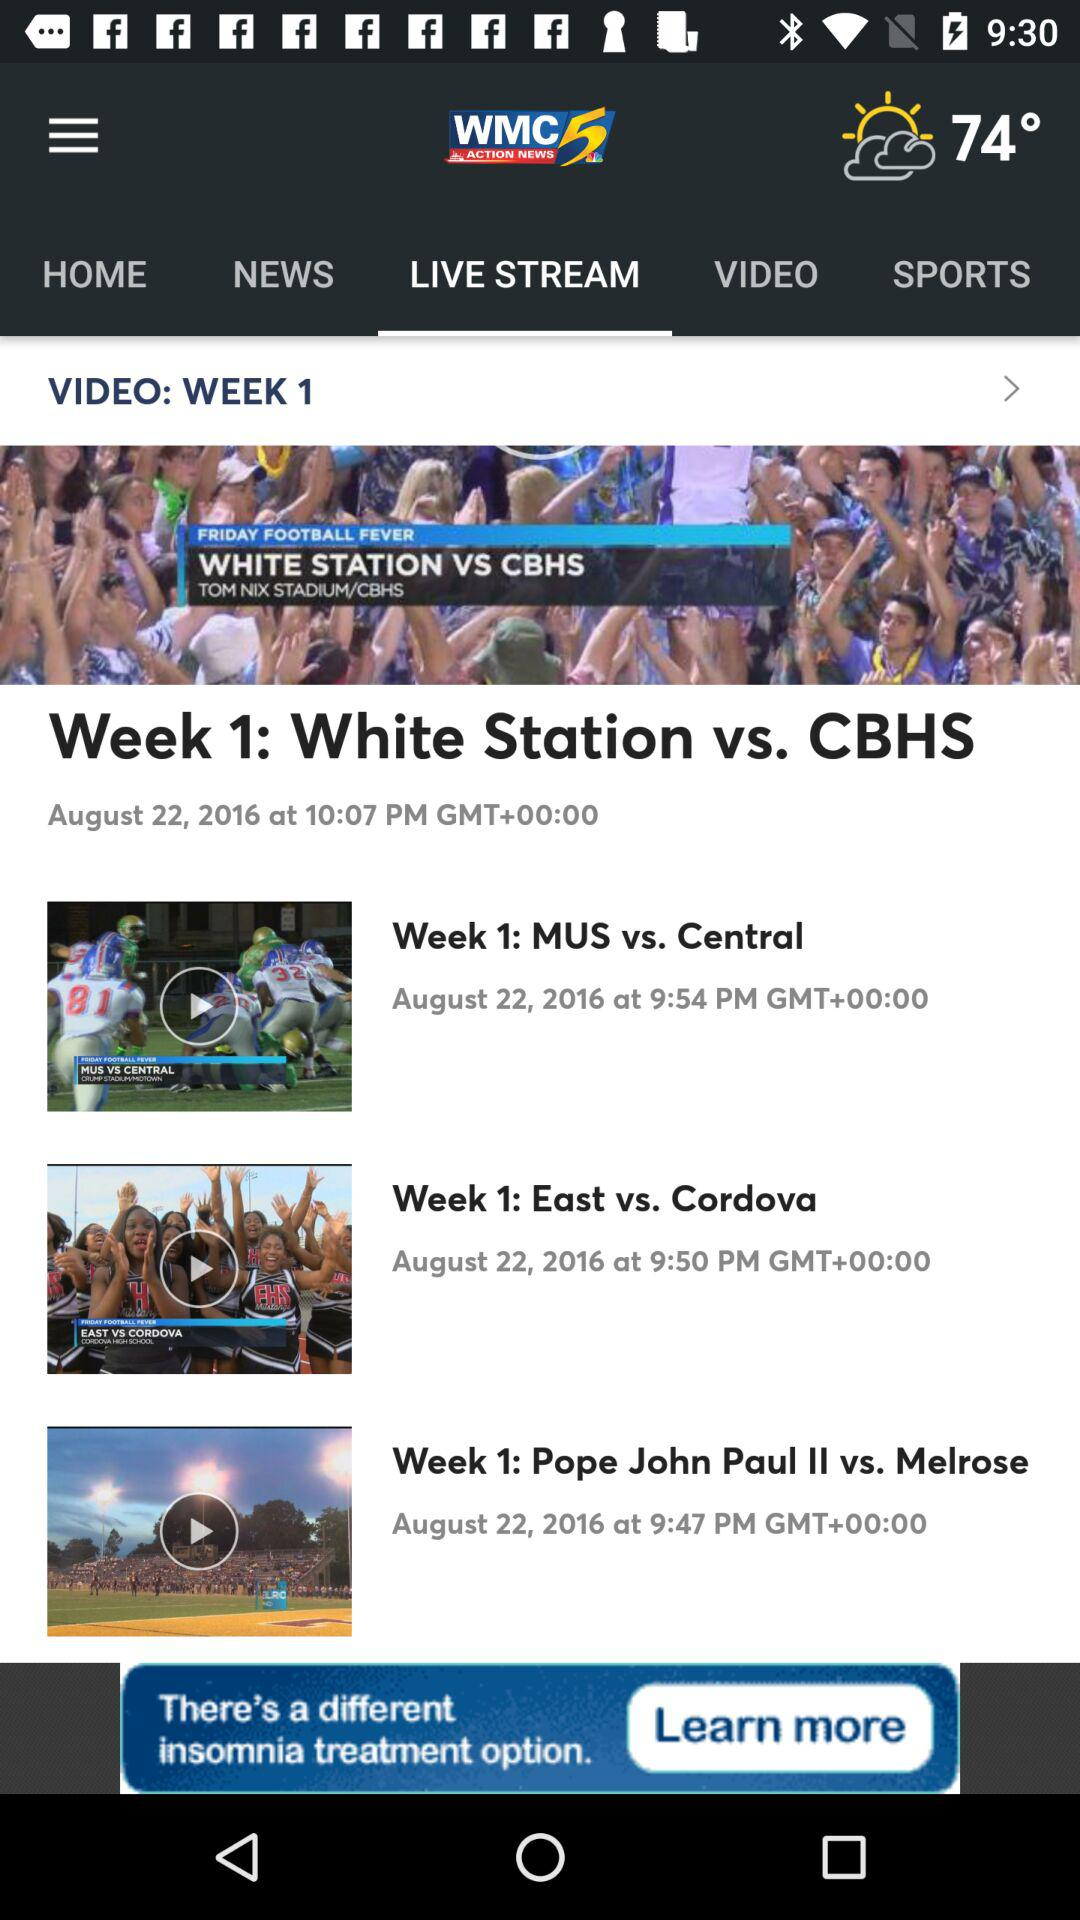Which tab is selected? The selected tab is "LIVE STREAM". 